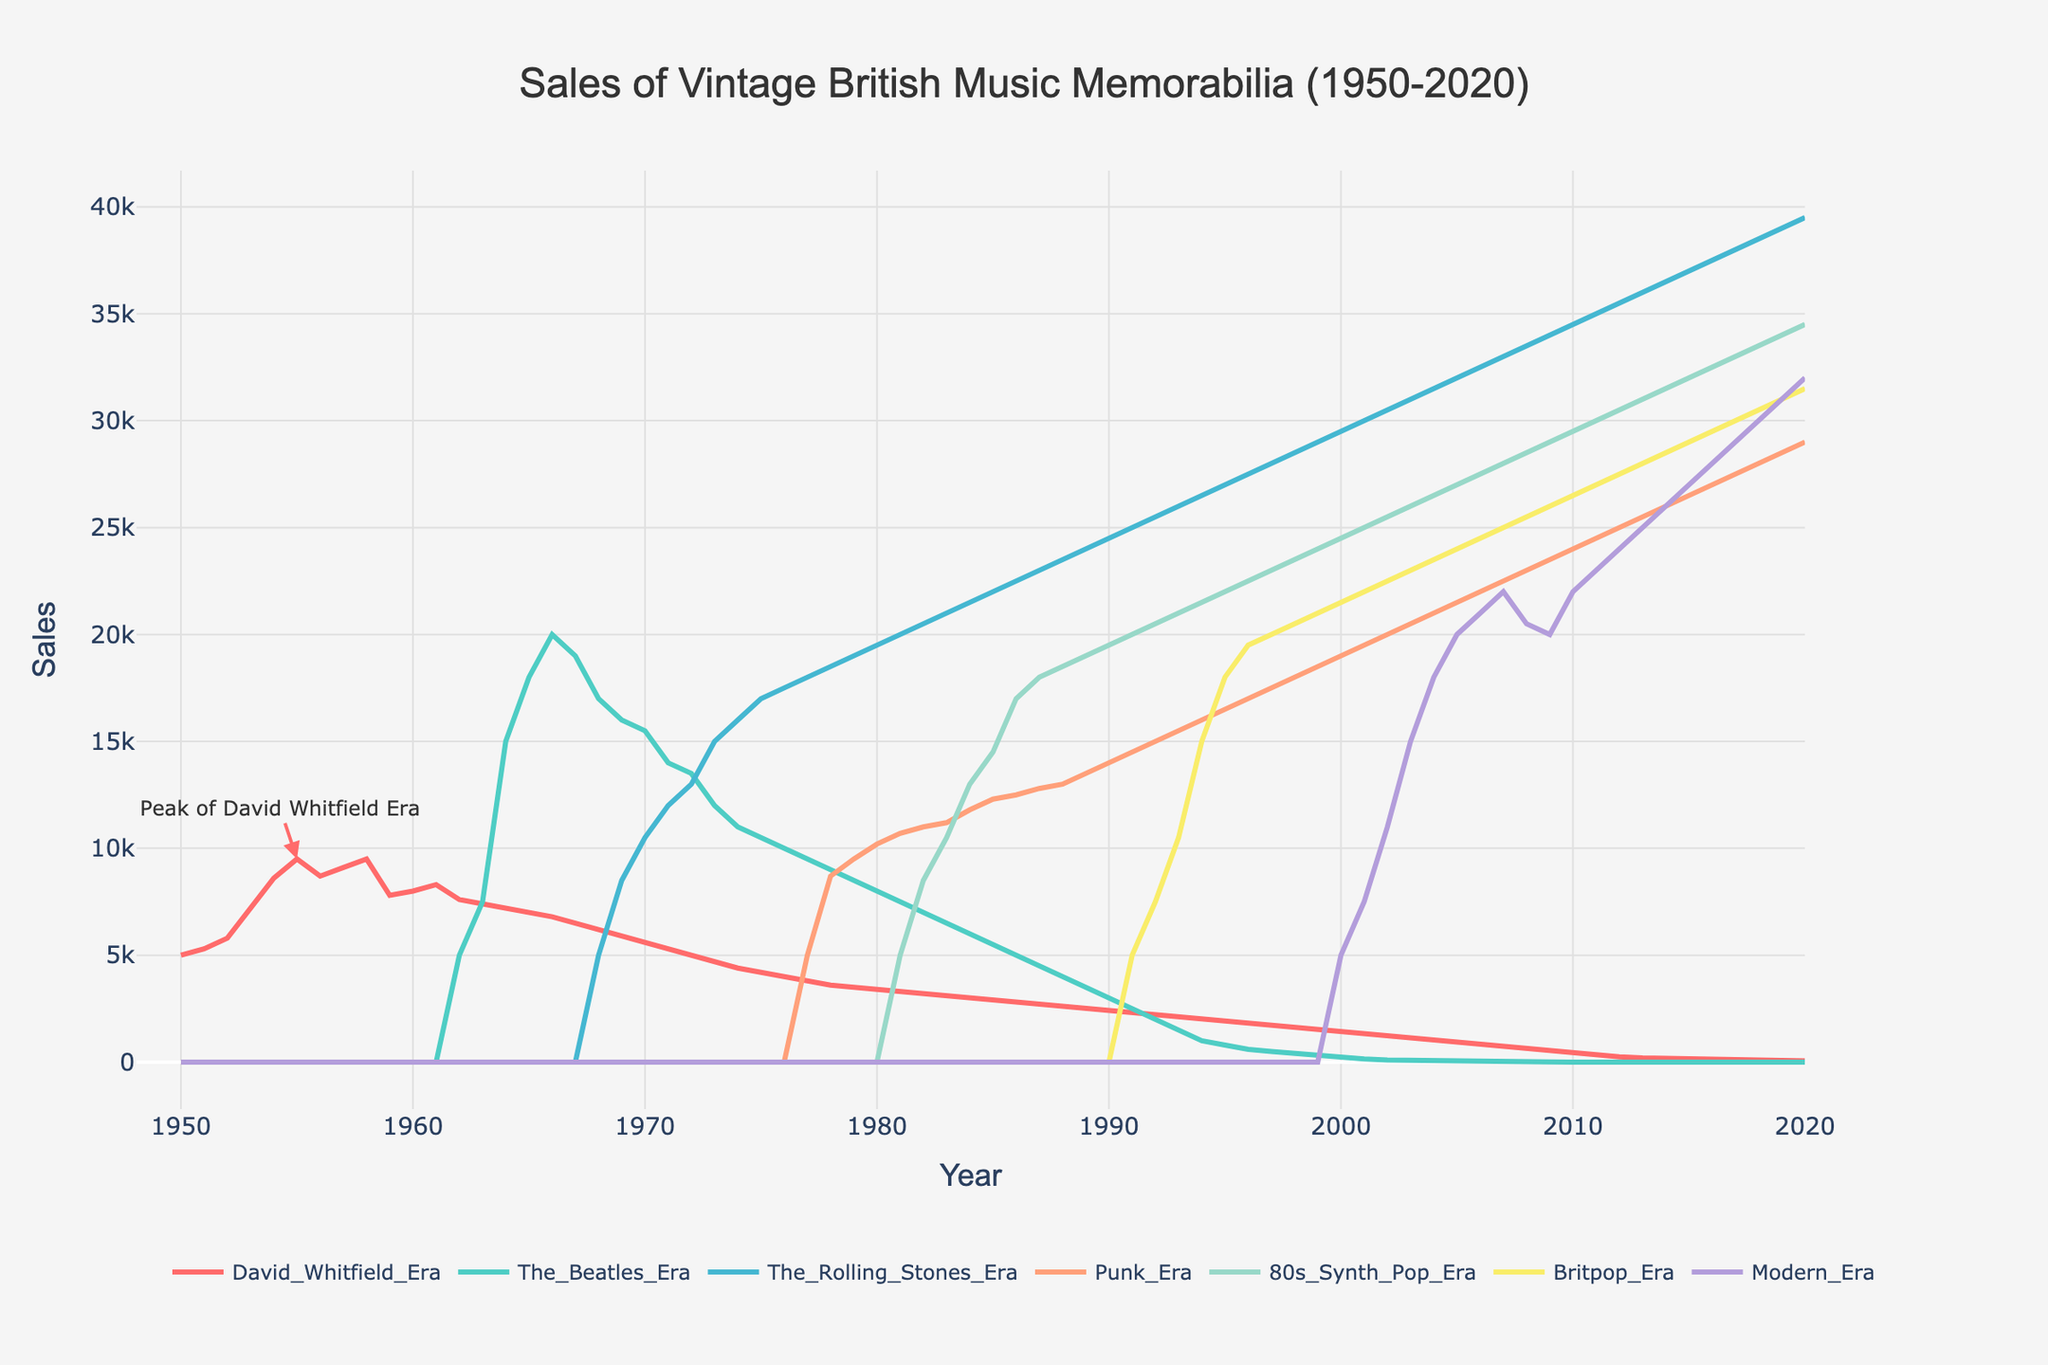What is the highest sales value of vintage British music memorabilia for the David Whitfield Era? The highest sales value for the David Whitfield Era is at the peak annotated in the figure, which is 9500 in 1955.
Answer: 9500 How do the sales trends for the David Whitfield Era and Beatles Era compare around 1962? By observing the plot around 1962, the sales for the David Whitfield Era are decreasing while the sales for the Beatles Era are starting to increase.
Answer: David Whitfield Era sales are decreasing, and Beatles Era sales are increasing During which year did the sales of Rolling Stones Era memorabilia first surpass the sales of David Whitfield Era memorabilia? By examining the figure, the Rolling Stones Era sales surpass the David Whitfield Era sales around 1969.
Answer: 1968 What's the trend in memorabilia sales for the Modern Era from 2000 to 2020? From 2000 to 2020, the Modern Era data exhibits a continuous upward trend in sales, gradually increasing each year.
Answer: Increasing Which era had the highest overall sales in the 1980s? Looking at the plot, the Rolling Stones Era consistently had the highest sales throughout the 1980s compared to other eras.
Answer: Rolling Stones Era How would you describe the variability in sales for the Punk Era compared to the Britpop Era? The Punk Era shows an initial increase in sales followed by a plateau, whereas the Britpop Era shows steady and moderate growth over the years.
Answer: Punk Era is more variable; Britpop Era is steadily growing What was the trend of sales for the Beatles Era from their peak until 1980? The Beatles Era sales peaked around 1966-1967 and then declined gradually until 1980.
Answer: Declining By how much did the sales of The Beatles Era memorabilia decline from 1966 to 1976? In 1966, The Beatles sales were at 20000. By 1976, they declined to 10000. The decline is 20000 - 10000 = 10000.
Answer: 10000 Compare the sales patterns of the Beatles Era and the 80s Synth Pop Era. The Beatles Era saw rapid growth in the 1960s followed by a decline. The 80s Synth Pop Era shows a steady rise from its start in the early 80s.
Answer: Beatles Era: rapid growth then decline, 80s Synth Pop Era: steady rise What annotation is present in the figure, and what does it indicate? The figure has an annotation around 1955 stating "Peak of David Whitfield Era".
Answer: Peak of David Whitfield Era (1955) 